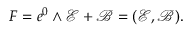Convert formula to latex. <formula><loc_0><loc_0><loc_500><loc_500>F = e ^ { 0 } \wedge \ m a t h s c r { E } + \ m a t h s c r { B } = ( \ m a t h s c r { E , \ m a t h s c r { B } } ) .</formula> 